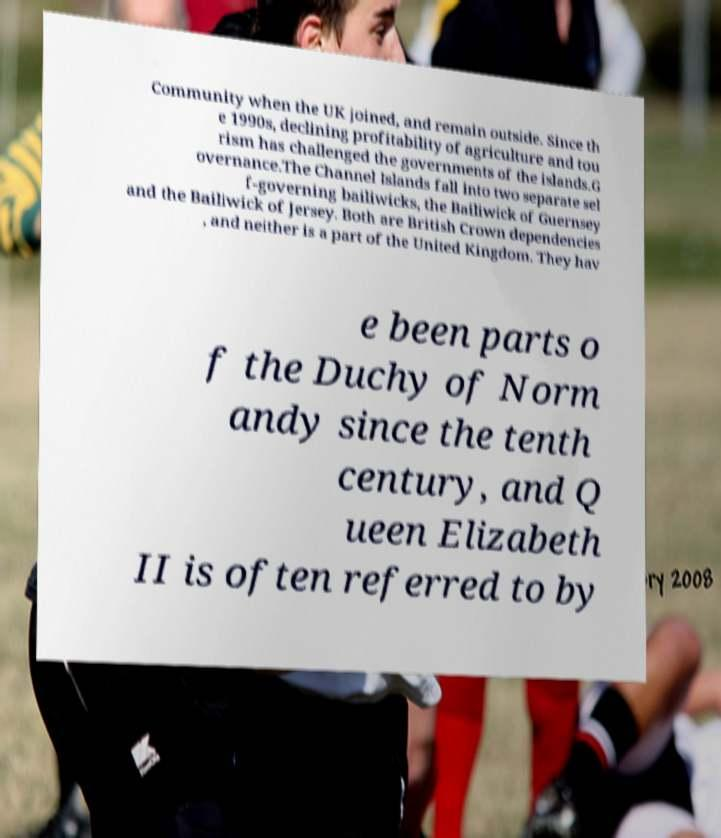Could you extract and type out the text from this image? Community when the UK joined, and remain outside. Since th e 1990s, declining profitability of agriculture and tou rism has challenged the governments of the islands.G overnance.The Channel Islands fall into two separate sel f-governing bailiwicks, the Bailiwick of Guernsey and the Bailiwick of Jersey. Both are British Crown dependencies , and neither is a part of the United Kingdom. They hav e been parts o f the Duchy of Norm andy since the tenth century, and Q ueen Elizabeth II is often referred to by 